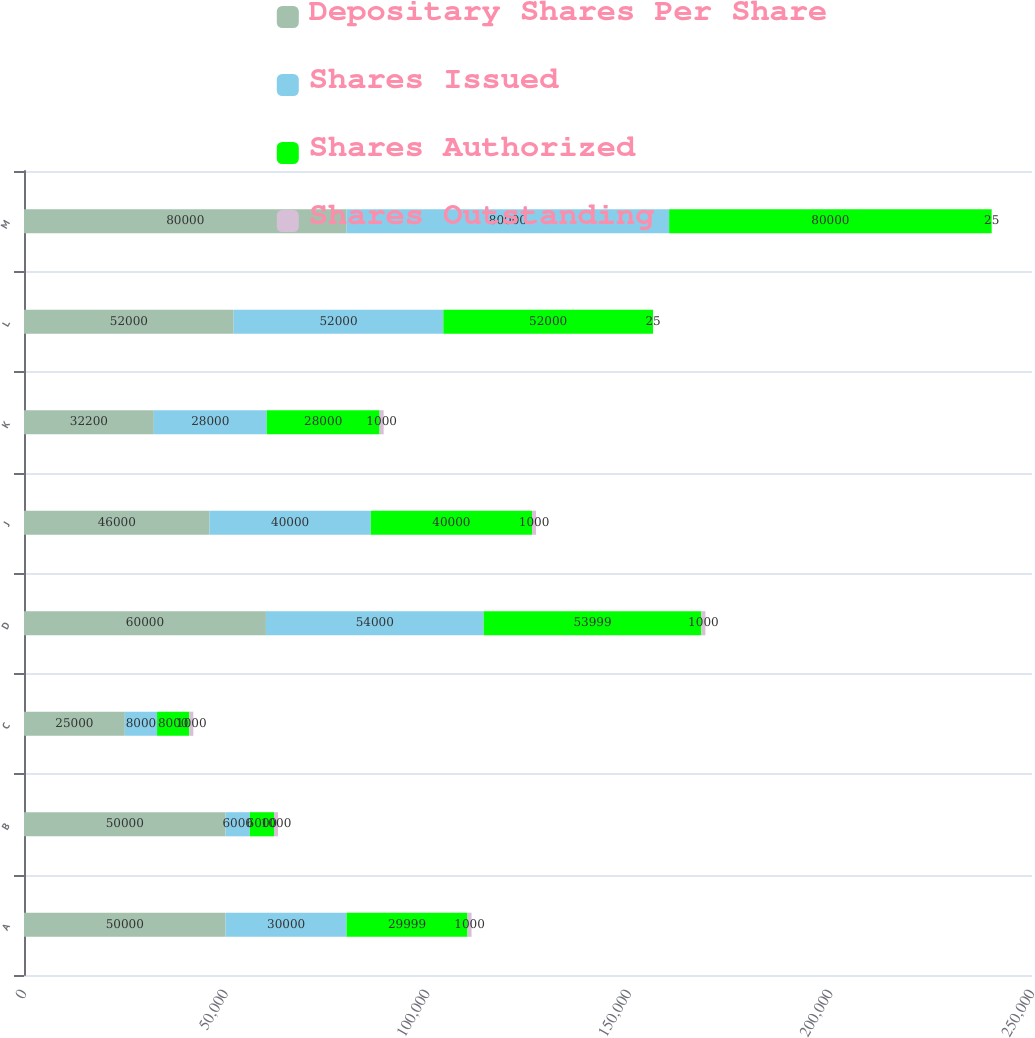<chart> <loc_0><loc_0><loc_500><loc_500><stacked_bar_chart><ecel><fcel>A<fcel>B<fcel>C<fcel>D<fcel>J<fcel>K<fcel>L<fcel>M<nl><fcel>Depositary Shares Per Share<fcel>50000<fcel>50000<fcel>25000<fcel>60000<fcel>46000<fcel>32200<fcel>52000<fcel>80000<nl><fcel>Shares Issued<fcel>30000<fcel>6000<fcel>8000<fcel>54000<fcel>40000<fcel>28000<fcel>52000<fcel>80000<nl><fcel>Shares Authorized<fcel>29999<fcel>6000<fcel>8000<fcel>53999<fcel>40000<fcel>28000<fcel>52000<fcel>80000<nl><fcel>Shares Outstanding<fcel>1000<fcel>1000<fcel>1000<fcel>1000<fcel>1000<fcel>1000<fcel>25<fcel>25<nl></chart> 